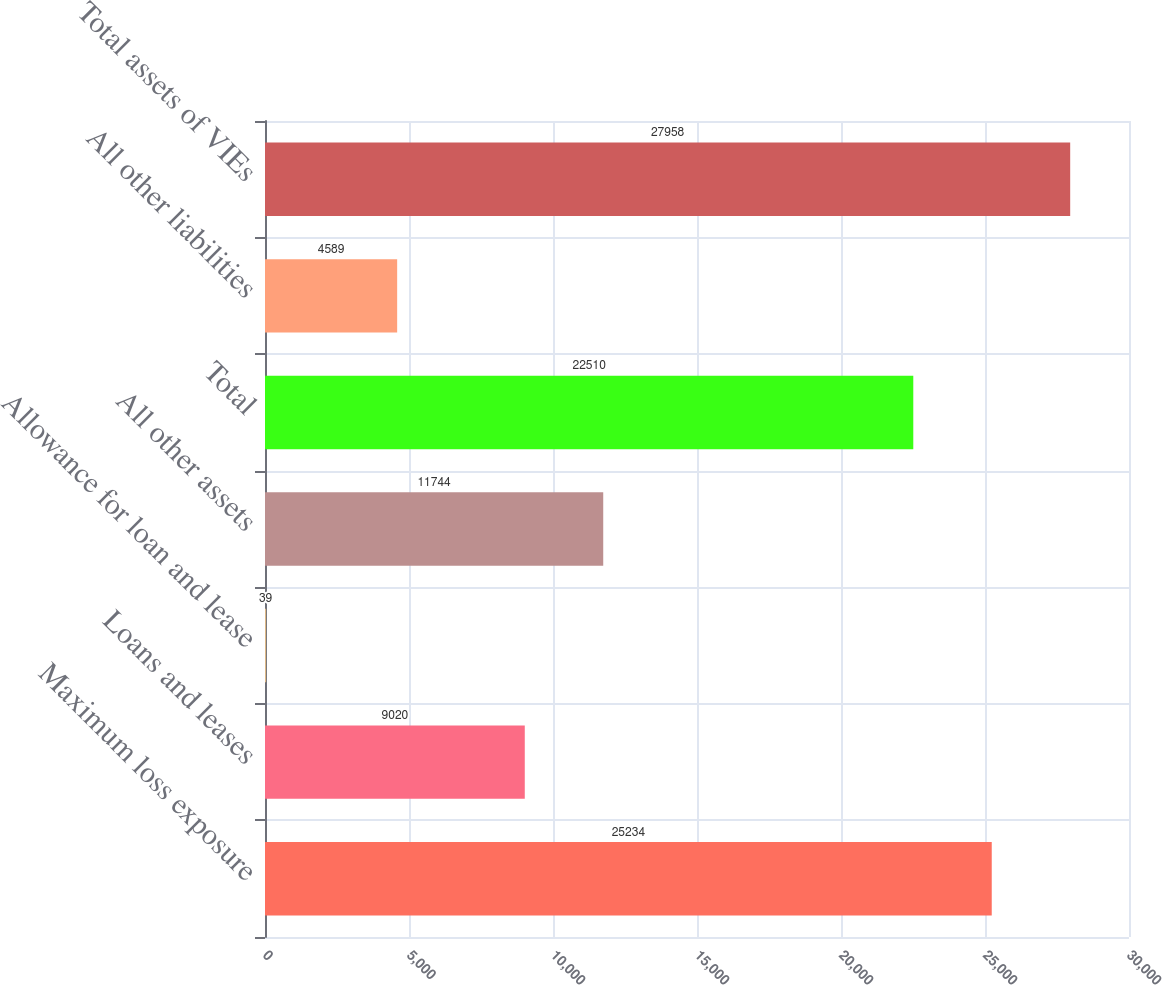Convert chart. <chart><loc_0><loc_0><loc_500><loc_500><bar_chart><fcel>Maximum loss exposure<fcel>Loans and leases<fcel>Allowance for loan and lease<fcel>All other assets<fcel>Total<fcel>All other liabilities<fcel>Total assets of VIEs<nl><fcel>25234<fcel>9020<fcel>39<fcel>11744<fcel>22510<fcel>4589<fcel>27958<nl></chart> 